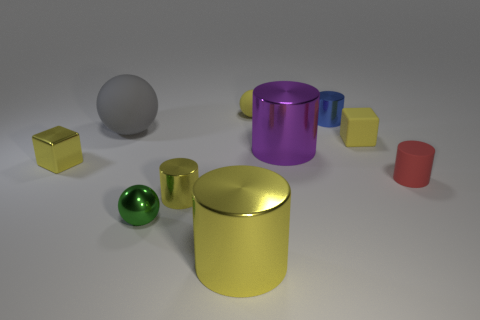Subtract all cubes. How many objects are left? 8 Add 2 purple objects. How many purple objects are left? 3 Add 5 tiny yellow balls. How many tiny yellow balls exist? 6 Subtract 0 brown cylinders. How many objects are left? 10 Subtract all big cylinders. Subtract all tiny cylinders. How many objects are left? 5 